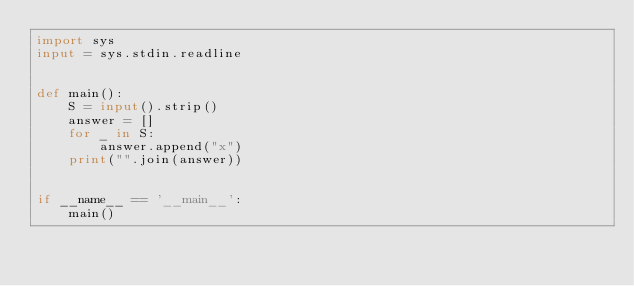Convert code to text. <code><loc_0><loc_0><loc_500><loc_500><_Python_>import sys
input = sys.stdin.readline


def main():
    S = input().strip()
    answer = []
    for _ in S:
        answer.append("x")
    print("".join(answer))


if __name__ == '__main__':
    main()
</code> 